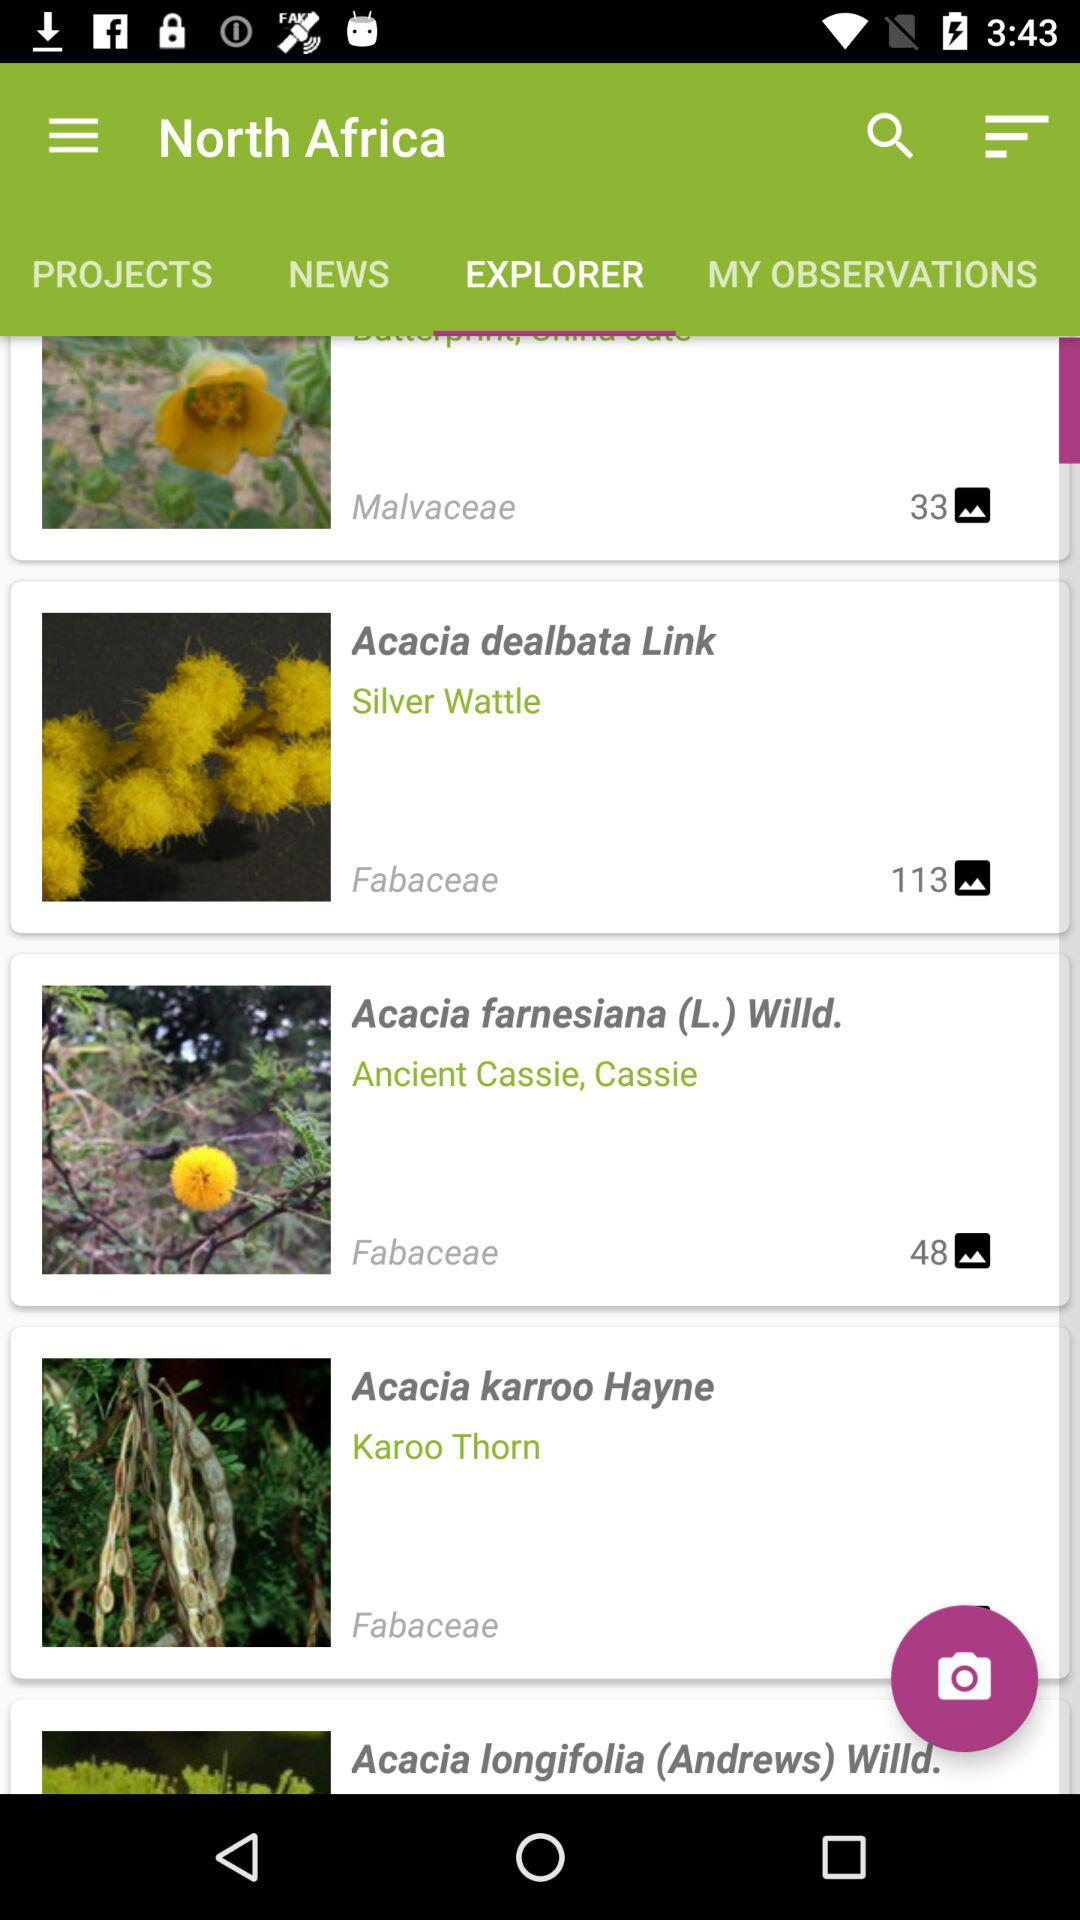Which tab is selected? The selected tab is 'EXPLORER,' which is highlighted with a darker shade of green compared to the other tabs, indicating it is currently active. This tab likely provides access to detailed exploratory features or content relevant to the displayed categories like different plant species. 